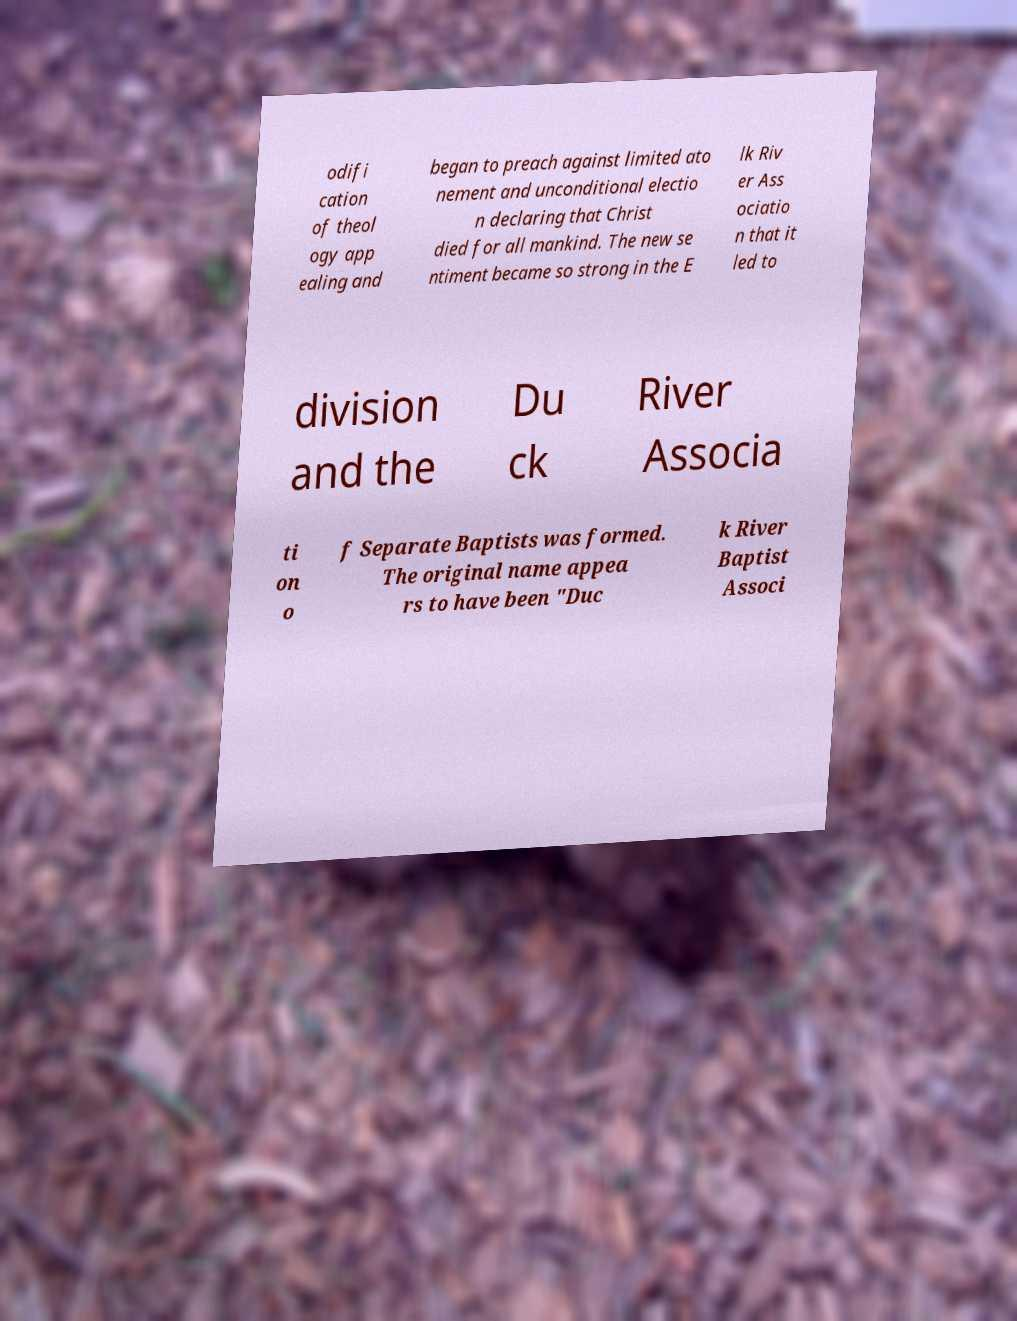Could you assist in decoding the text presented in this image and type it out clearly? odifi cation of theol ogy app ealing and began to preach against limited ato nement and unconditional electio n declaring that Christ died for all mankind. The new se ntiment became so strong in the E lk Riv er Ass ociatio n that it led to division and the Du ck River Associa ti on o f Separate Baptists was formed. The original name appea rs to have been "Duc k River Baptist Associ 